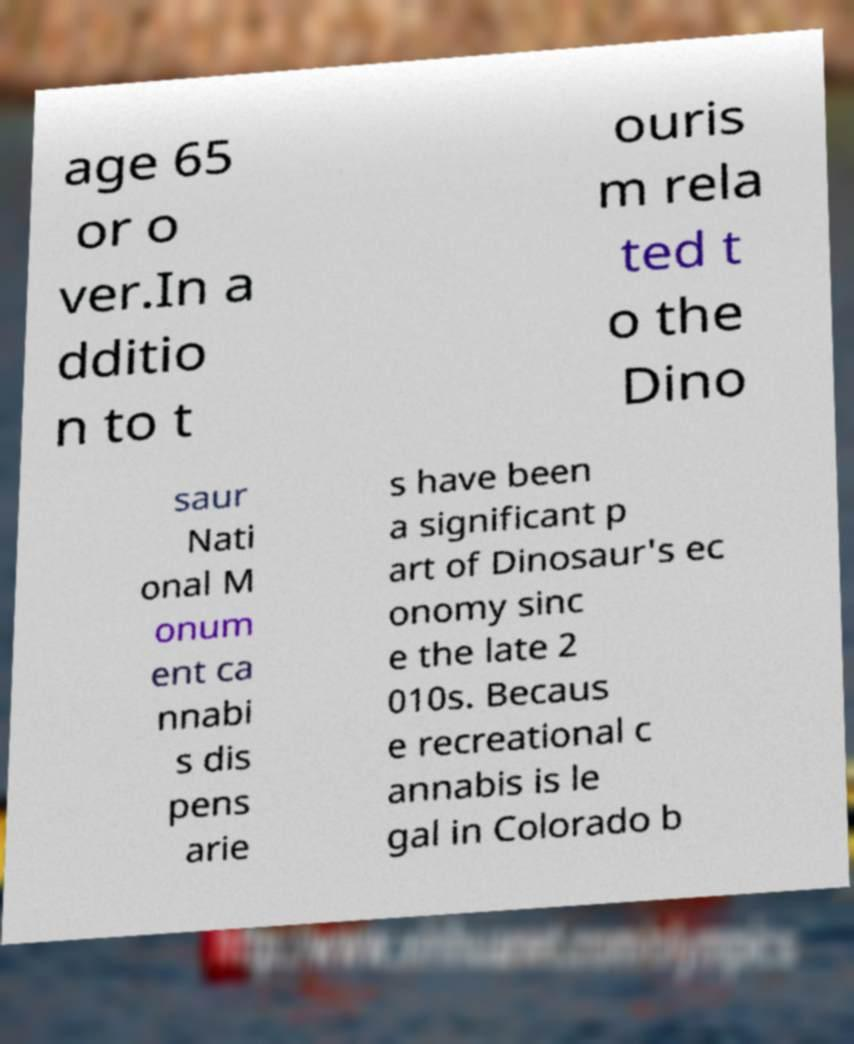For documentation purposes, I need the text within this image transcribed. Could you provide that? age 65 or o ver.In a dditio n to t ouris m rela ted t o the Dino saur Nati onal M onum ent ca nnabi s dis pens arie s have been a significant p art of Dinosaur's ec onomy sinc e the late 2 010s. Becaus e recreational c annabis is le gal in Colorado b 